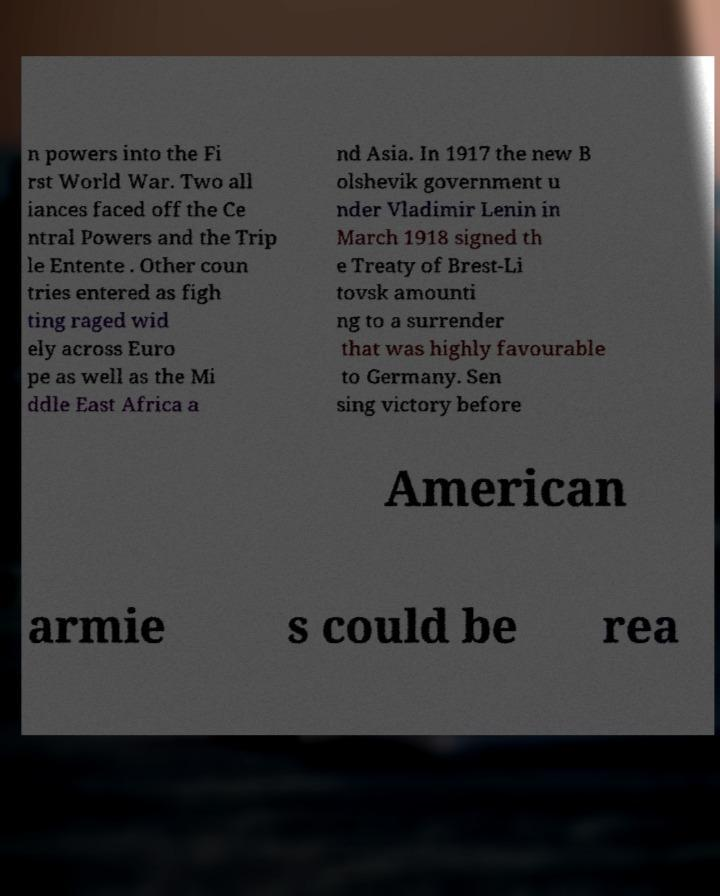For documentation purposes, I need the text within this image transcribed. Could you provide that? n powers into the Fi rst World War. Two all iances faced off the Ce ntral Powers and the Trip le Entente . Other coun tries entered as figh ting raged wid ely across Euro pe as well as the Mi ddle East Africa a nd Asia. In 1917 the new B olshevik government u nder Vladimir Lenin in March 1918 signed th e Treaty of Brest-Li tovsk amounti ng to a surrender that was highly favourable to Germany. Sen sing victory before American armie s could be rea 